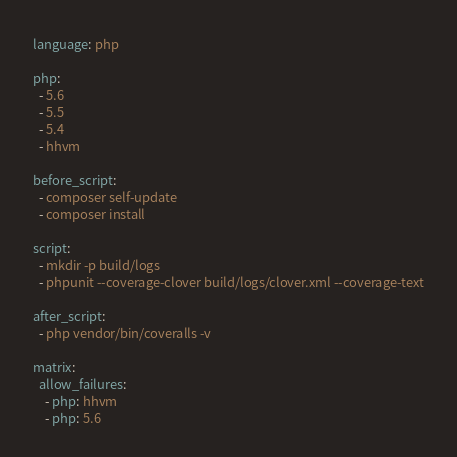<code> <loc_0><loc_0><loc_500><loc_500><_YAML_>language: php

php:
  - 5.6
  - 5.5
  - 5.4
  - hhvm

before_script:
  - composer self-update
  - composer install

script:
  - mkdir -p build/logs
  - phpunit --coverage-clover build/logs/clover.xml --coverage-text

after_script:
  - php vendor/bin/coveralls -v

matrix:
  allow_failures:
    - php: hhvm
    - php: 5.6</code> 